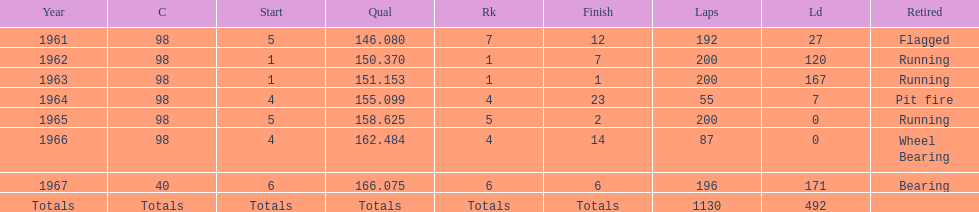What year(s) did parnelli finish at least 4th or better? 1963, 1965. 